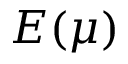Convert formula to latex. <formula><loc_0><loc_0><loc_500><loc_500>E ( \mu )</formula> 